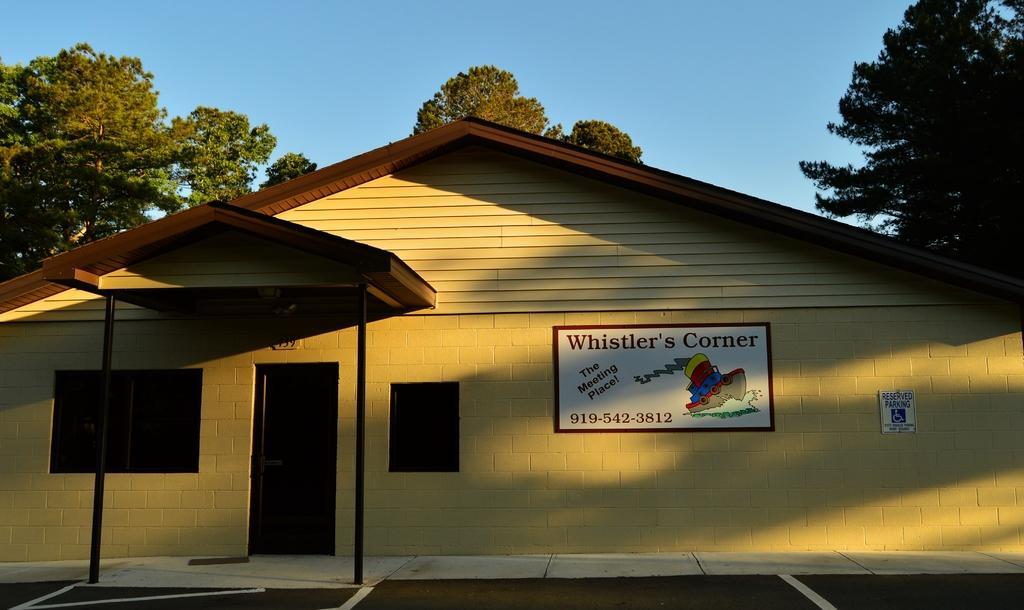In one or two sentences, can you explain what this image depicts? In this image in the center there is a house and on the wall of the house there are boards with some text and numbers written on it. In the background there are trees and in front of the house there is a shelter and there are poles, there is a road and at the top there is sky. 